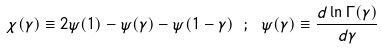<formula> <loc_0><loc_0><loc_500><loc_500>\chi ( \gamma ) \equiv 2 \psi ( 1 ) - \psi ( \gamma ) - \psi ( 1 - \gamma ) \ ; \ \psi ( \gamma ) \equiv \frac { d \ln \Gamma ( \gamma ) } { d \gamma }</formula> 